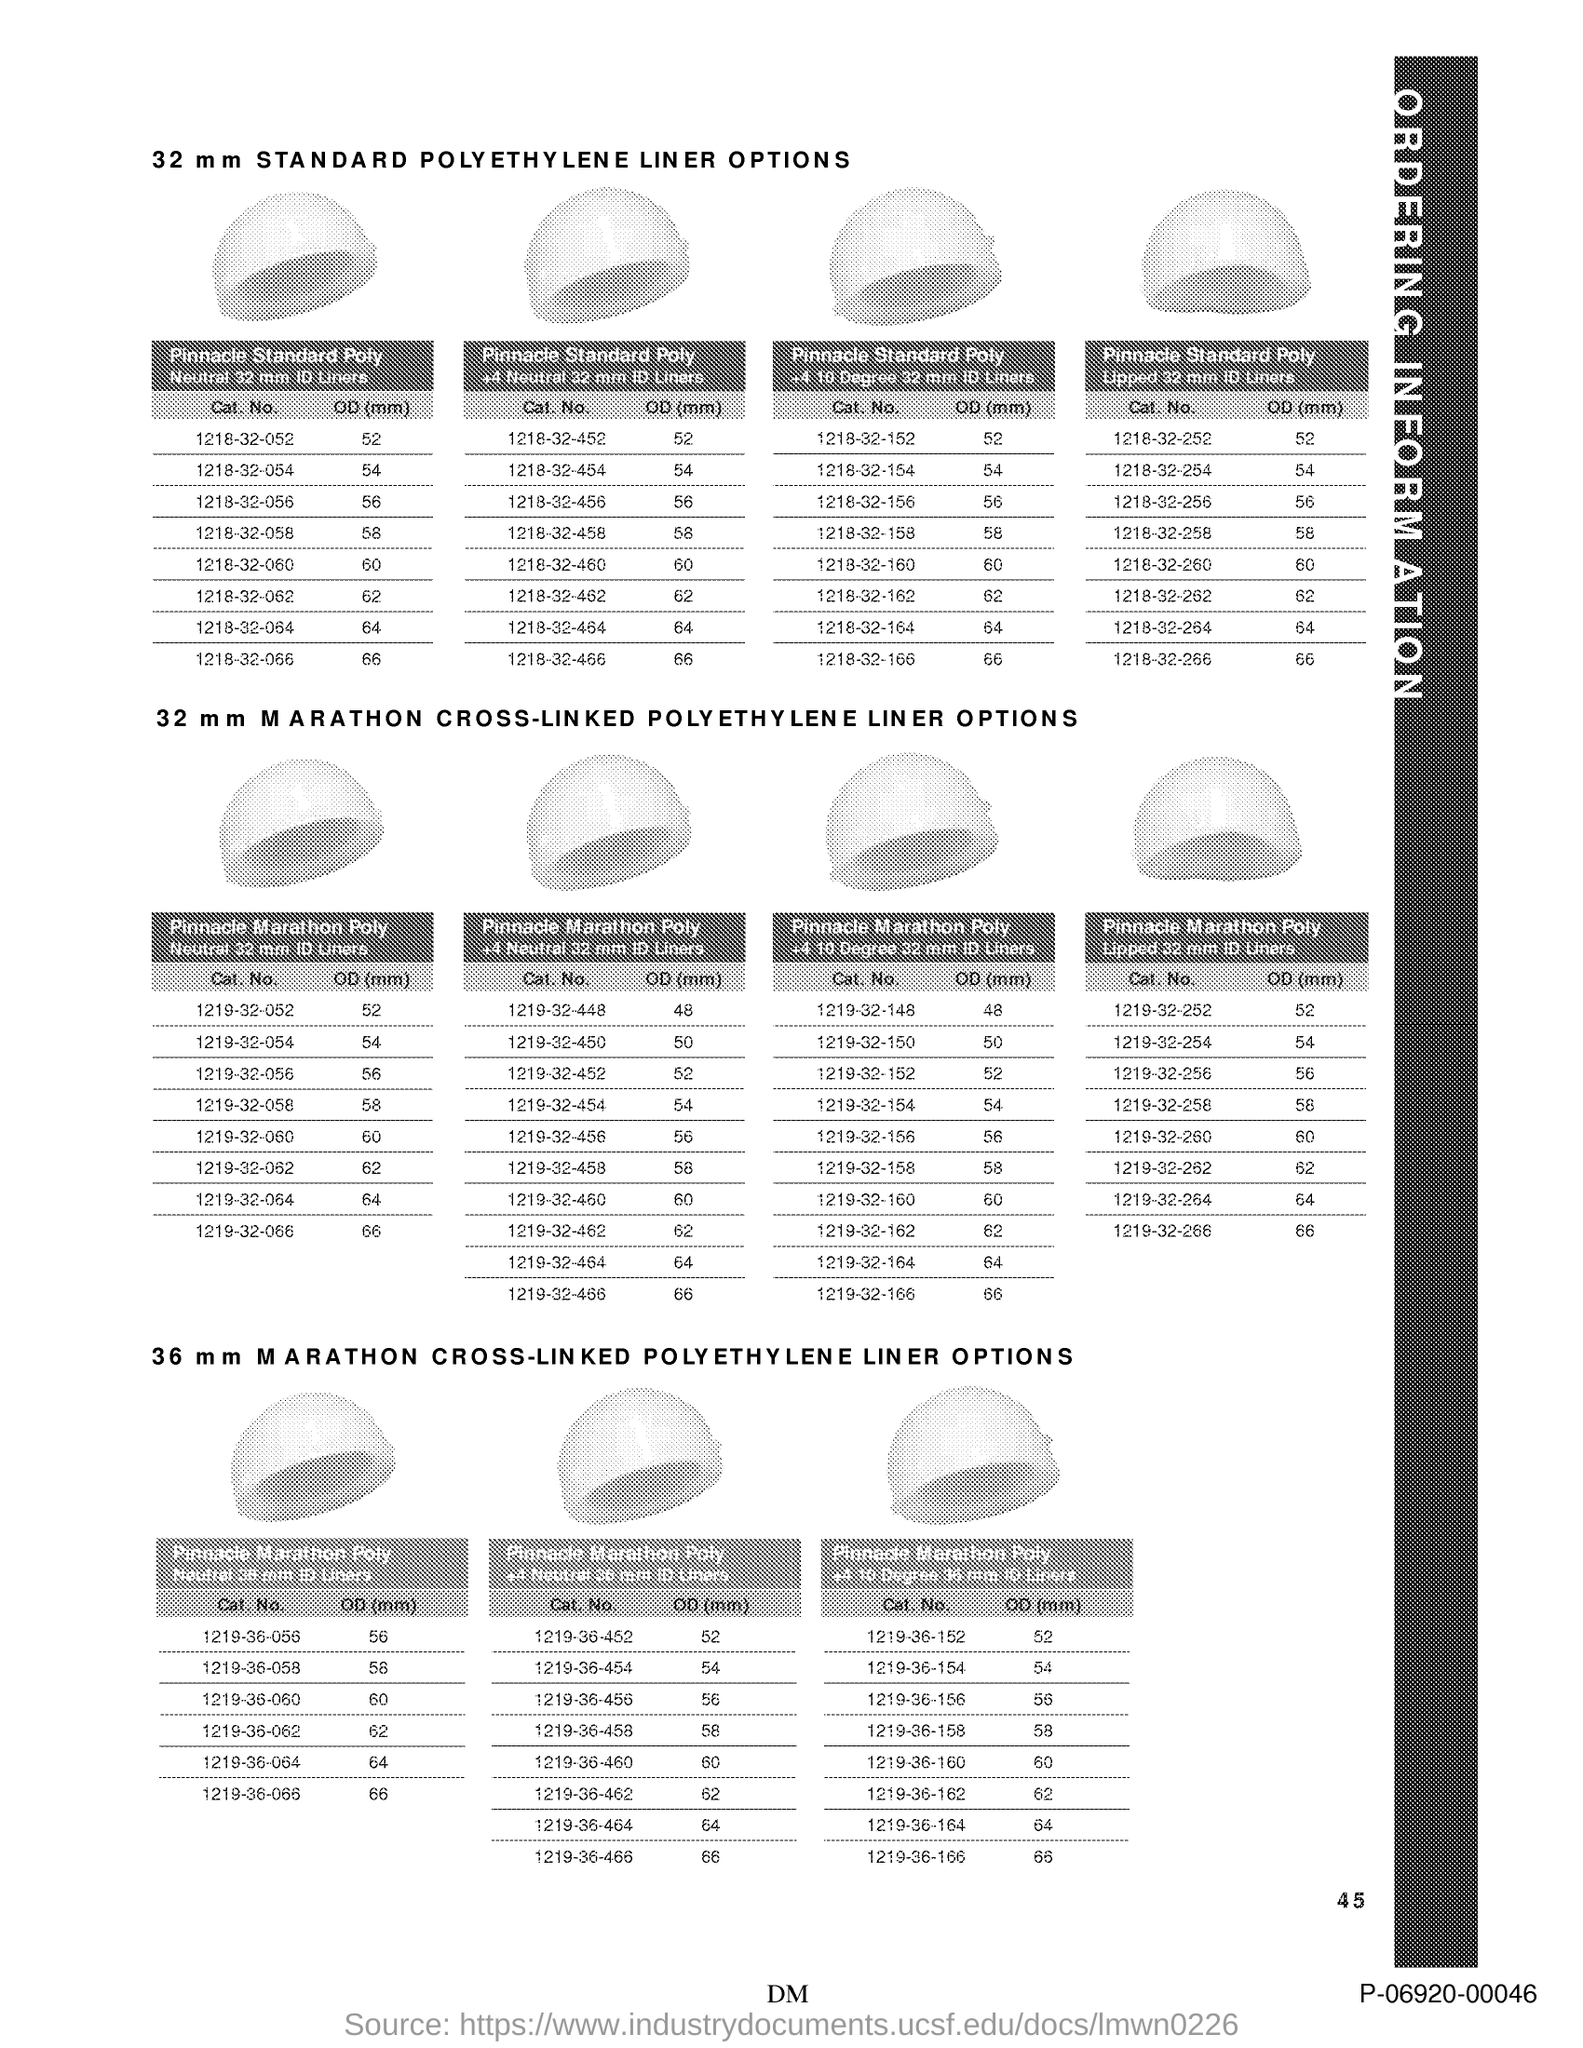What is the Page Number?
Give a very brief answer. 45. 